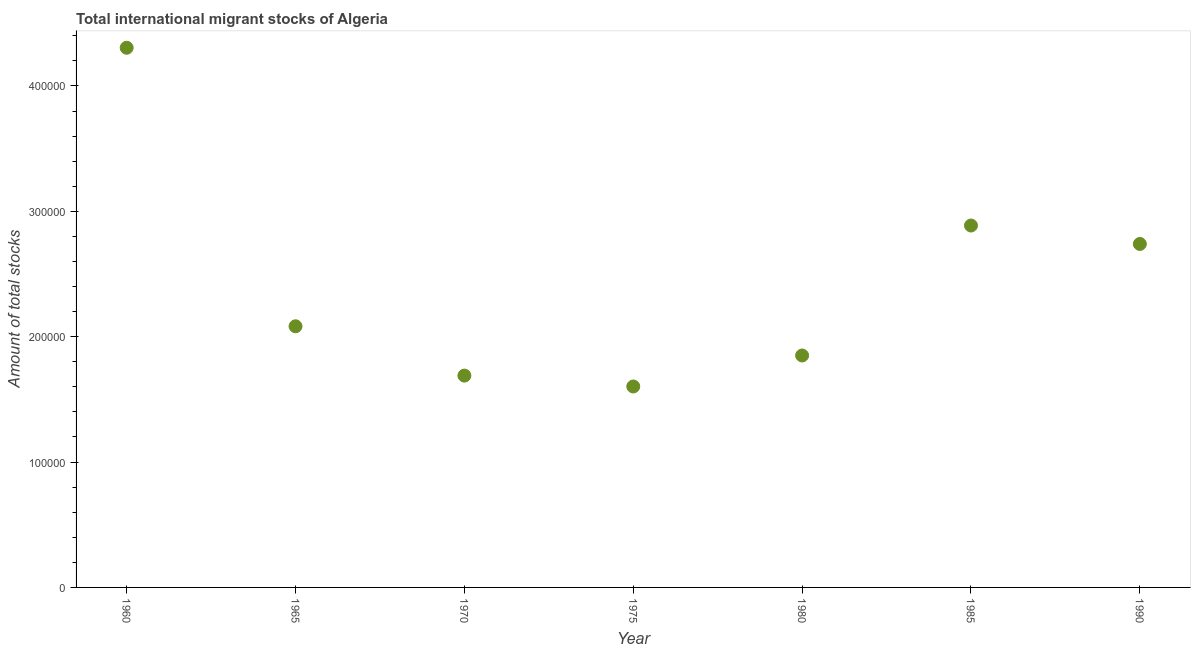What is the total number of international migrant stock in 1960?
Ensure brevity in your answer.  4.30e+05. Across all years, what is the maximum total number of international migrant stock?
Your response must be concise. 4.30e+05. Across all years, what is the minimum total number of international migrant stock?
Provide a short and direct response. 1.60e+05. In which year was the total number of international migrant stock maximum?
Offer a very short reply. 1960. In which year was the total number of international migrant stock minimum?
Your response must be concise. 1975. What is the sum of the total number of international migrant stock?
Provide a short and direct response. 1.72e+06. What is the difference between the total number of international migrant stock in 1980 and 1990?
Offer a terse response. -8.90e+04. What is the average total number of international migrant stock per year?
Your response must be concise. 2.45e+05. What is the median total number of international migrant stock?
Offer a terse response. 2.08e+05. What is the ratio of the total number of international migrant stock in 1975 to that in 1980?
Your answer should be very brief. 0.87. Is the total number of international migrant stock in 1965 less than that in 1985?
Offer a very short reply. Yes. What is the difference between the highest and the second highest total number of international migrant stock?
Provide a short and direct response. 1.42e+05. What is the difference between the highest and the lowest total number of international migrant stock?
Ensure brevity in your answer.  2.70e+05. In how many years, is the total number of international migrant stock greater than the average total number of international migrant stock taken over all years?
Your answer should be compact. 3. How many years are there in the graph?
Offer a terse response. 7. What is the title of the graph?
Offer a very short reply. Total international migrant stocks of Algeria. What is the label or title of the Y-axis?
Provide a succinct answer. Amount of total stocks. What is the Amount of total stocks in 1960?
Provide a succinct answer. 4.30e+05. What is the Amount of total stocks in 1965?
Your answer should be very brief. 2.08e+05. What is the Amount of total stocks in 1970?
Offer a very short reply. 1.69e+05. What is the Amount of total stocks in 1975?
Offer a very short reply. 1.60e+05. What is the Amount of total stocks in 1980?
Give a very brief answer. 1.85e+05. What is the Amount of total stocks in 1985?
Offer a very short reply. 2.89e+05. What is the Amount of total stocks in 1990?
Provide a short and direct response. 2.74e+05. What is the difference between the Amount of total stocks in 1960 and 1965?
Provide a short and direct response. 2.22e+05. What is the difference between the Amount of total stocks in 1960 and 1970?
Offer a very short reply. 2.61e+05. What is the difference between the Amount of total stocks in 1960 and 1975?
Keep it short and to the point. 2.70e+05. What is the difference between the Amount of total stocks in 1960 and 1980?
Make the answer very short. 2.45e+05. What is the difference between the Amount of total stocks in 1960 and 1985?
Give a very brief answer. 1.42e+05. What is the difference between the Amount of total stocks in 1960 and 1990?
Your answer should be very brief. 1.56e+05. What is the difference between the Amount of total stocks in 1965 and 1970?
Keep it short and to the point. 3.94e+04. What is the difference between the Amount of total stocks in 1965 and 1975?
Provide a succinct answer. 4.80e+04. What is the difference between the Amount of total stocks in 1965 and 1980?
Your answer should be compact. 2.33e+04. What is the difference between the Amount of total stocks in 1965 and 1985?
Provide a succinct answer. -8.04e+04. What is the difference between the Amount of total stocks in 1965 and 1990?
Provide a succinct answer. -6.57e+04. What is the difference between the Amount of total stocks in 1970 and 1975?
Give a very brief answer. 8662. What is the difference between the Amount of total stocks in 1970 and 1980?
Ensure brevity in your answer.  -1.60e+04. What is the difference between the Amount of total stocks in 1970 and 1985?
Provide a succinct answer. -1.20e+05. What is the difference between the Amount of total stocks in 1970 and 1990?
Provide a short and direct response. -1.05e+05. What is the difference between the Amount of total stocks in 1975 and 1980?
Offer a terse response. -2.47e+04. What is the difference between the Amount of total stocks in 1975 and 1985?
Offer a very short reply. -1.28e+05. What is the difference between the Amount of total stocks in 1975 and 1990?
Offer a very short reply. -1.14e+05. What is the difference between the Amount of total stocks in 1980 and 1985?
Keep it short and to the point. -1.04e+05. What is the difference between the Amount of total stocks in 1980 and 1990?
Your answer should be compact. -8.90e+04. What is the difference between the Amount of total stocks in 1985 and 1990?
Offer a terse response. 1.47e+04. What is the ratio of the Amount of total stocks in 1960 to that in 1965?
Make the answer very short. 2.07. What is the ratio of the Amount of total stocks in 1960 to that in 1970?
Your answer should be very brief. 2.55. What is the ratio of the Amount of total stocks in 1960 to that in 1975?
Keep it short and to the point. 2.69. What is the ratio of the Amount of total stocks in 1960 to that in 1980?
Ensure brevity in your answer.  2.33. What is the ratio of the Amount of total stocks in 1960 to that in 1985?
Your answer should be compact. 1.49. What is the ratio of the Amount of total stocks in 1960 to that in 1990?
Provide a succinct answer. 1.57. What is the ratio of the Amount of total stocks in 1965 to that in 1970?
Your answer should be compact. 1.23. What is the ratio of the Amount of total stocks in 1965 to that in 1975?
Make the answer very short. 1.3. What is the ratio of the Amount of total stocks in 1965 to that in 1980?
Make the answer very short. 1.13. What is the ratio of the Amount of total stocks in 1965 to that in 1985?
Offer a very short reply. 0.72. What is the ratio of the Amount of total stocks in 1965 to that in 1990?
Provide a succinct answer. 0.76. What is the ratio of the Amount of total stocks in 1970 to that in 1975?
Ensure brevity in your answer.  1.05. What is the ratio of the Amount of total stocks in 1970 to that in 1985?
Give a very brief answer. 0.58. What is the ratio of the Amount of total stocks in 1970 to that in 1990?
Your answer should be very brief. 0.62. What is the ratio of the Amount of total stocks in 1975 to that in 1980?
Your response must be concise. 0.87. What is the ratio of the Amount of total stocks in 1975 to that in 1985?
Provide a succinct answer. 0.56. What is the ratio of the Amount of total stocks in 1975 to that in 1990?
Keep it short and to the point. 0.58. What is the ratio of the Amount of total stocks in 1980 to that in 1985?
Give a very brief answer. 0.64. What is the ratio of the Amount of total stocks in 1980 to that in 1990?
Your answer should be compact. 0.68. What is the ratio of the Amount of total stocks in 1985 to that in 1990?
Provide a short and direct response. 1.05. 